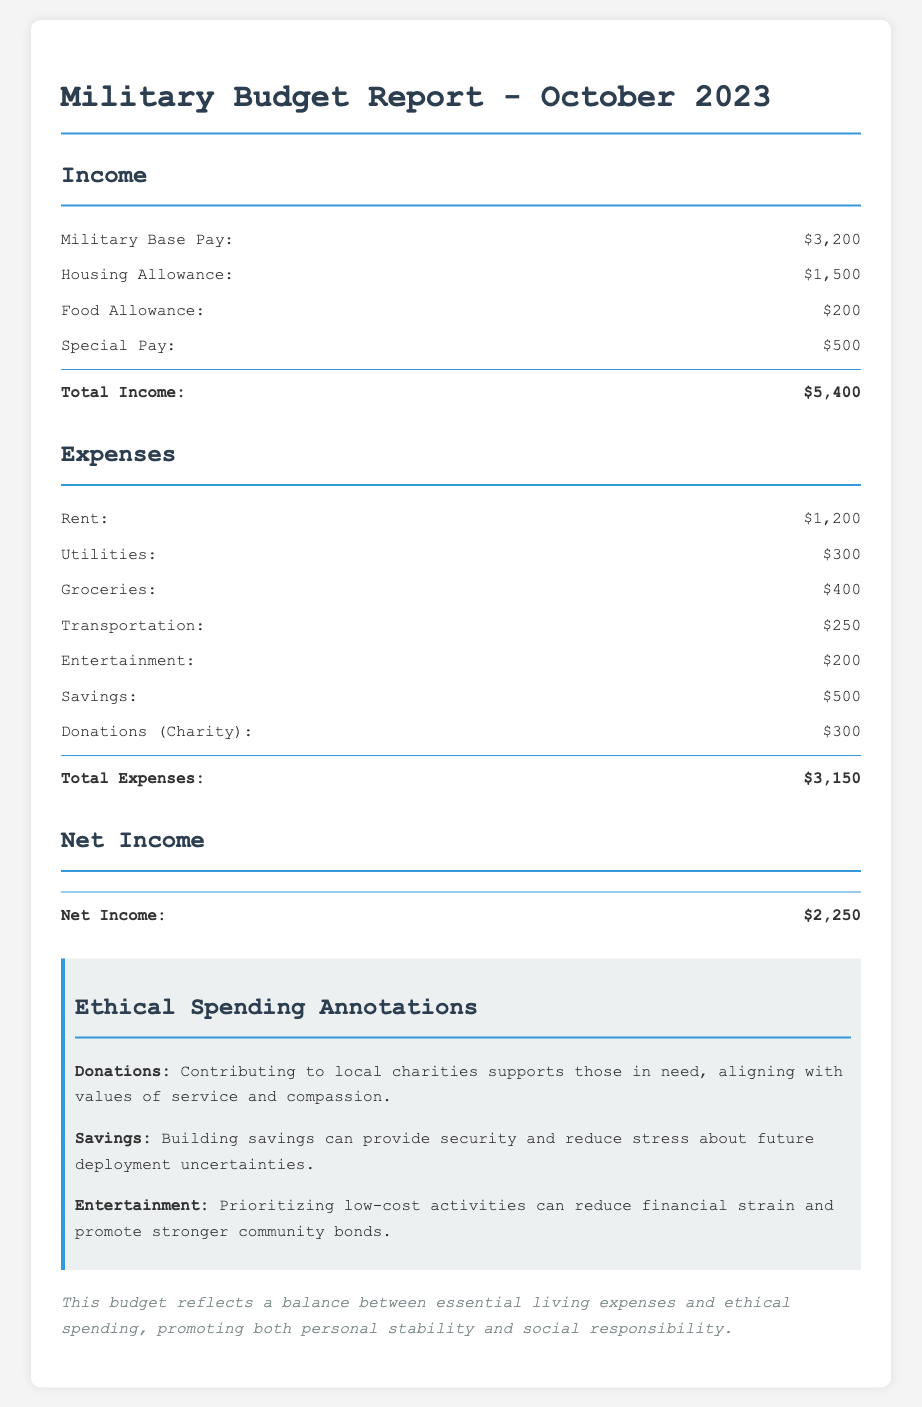What is the total income? The total income is calculated by adding up all the income sources, which amounts to $3,200 + $1,500 + $200 + $500 = $5,400.
Answer: $5,400 What is the housing allowance? The housing allowance is specifically listed under income as $1,500.
Answer: $1,500 What is the total expenses? Total expenses are determined by summing up all the listed expenses, which totals $1,200 + $300 + $400 + $250 + $200 + $500 + $300 = $3,150.
Answer: $3,150 What is the net income? Net income is derived by subtracting total expenses from total income, in this case, $5,400 - $3,150 = $2,250.
Answer: $2,250 What amount was allocated for donations? The document specifies that $300 is allocated for donations (charity) under expenses.
Answer: $300 Why is building savings considered ethical? Building savings is seen as ethical because it provides security and reduces future deployment uncertainties, as noted in the annotations.
Answer: Security What type of activities are recommended for entertainment? The document suggests prioritizing low-cost activities as a strategy for entertainment.
Answer: Low-cost activities What are the essential living expenses mentioned? Essential living expenses include rent, utilities, groceries, and transportation, as reflected in the expense section.
Answer: Rent, utilities, groceries, transportation What is the purpose of the ethical spending annotations? The annotations aim to highlight the significance of certain spending behaviors in supporting social responsibility and personal stability.
Answer: Social responsibility 